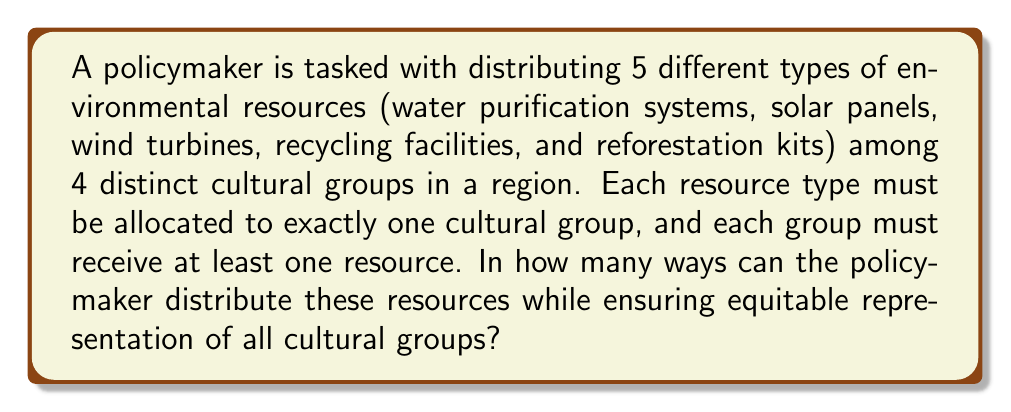Help me with this question. To solve this problem, we can use the concept of stirling numbers of the second kind and multiply it by the number of permutations of the cultural groups.

1) First, we need to calculate the number of ways to partition 5 distinct objects (resources) into 4 non-empty subsets (cultural groups). This is given by the Stirling number of the second kind, denoted as $\stirling{5}{4}$.

2) The formula for $\stirling{5}{4}$ is:

   $$\stirling{5}{4} = \frac{1}{4!}\sum_{i=0}^4 (-1)^i \binom{4}{i}(4-i)^5$$

3) Expanding this:
   $$\stirling{5}{4} = \frac{1}{24}[(4^5) - 4(3^5) + 6(2^5) - 4(1^5) + 0]$$
   $$= \frac{1}{24}[1024 - 972 + 192 - 4 + 0] = \frac{240}{24} = 10$$

4) This gives us the number of ways to distribute the resources into 4 groups, but we still need to consider the order of the cultural groups.

5) There are 4! = 24 ways to order the 4 cultural groups.

6) By the multiplication principle, the total number of ways to distribute the resources is:

   $$10 \times 24 = 240$$

Therefore, there are 240 ways for the policymaker to distribute the environmental resources among the four cultural groups.
Answer: 240 ways 